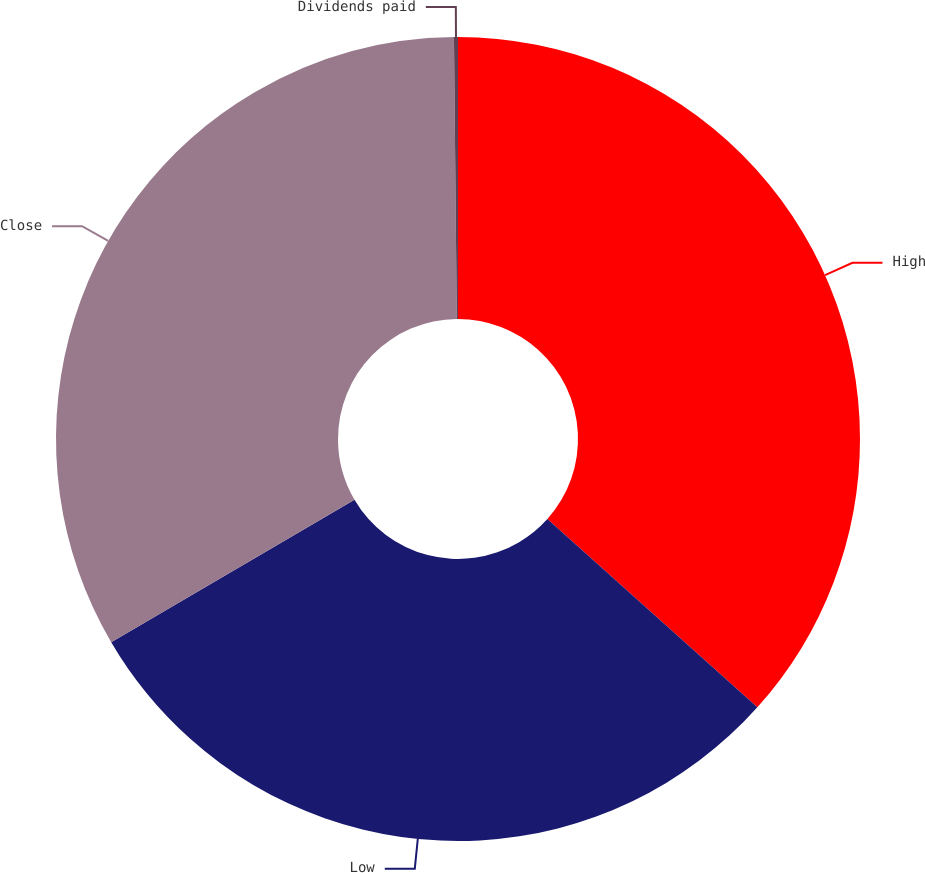Convert chart to OTSL. <chart><loc_0><loc_0><loc_500><loc_500><pie_chart><fcel>High<fcel>Low<fcel>Close<fcel>Dividends paid<nl><fcel>36.63%<fcel>29.93%<fcel>33.28%<fcel>0.16%<nl></chart> 